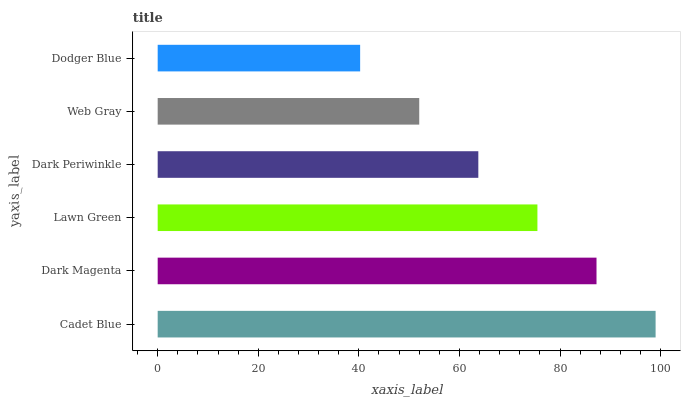Is Dodger Blue the minimum?
Answer yes or no. Yes. Is Cadet Blue the maximum?
Answer yes or no. Yes. Is Dark Magenta the minimum?
Answer yes or no. No. Is Dark Magenta the maximum?
Answer yes or no. No. Is Cadet Blue greater than Dark Magenta?
Answer yes or no. Yes. Is Dark Magenta less than Cadet Blue?
Answer yes or no. Yes. Is Dark Magenta greater than Cadet Blue?
Answer yes or no. No. Is Cadet Blue less than Dark Magenta?
Answer yes or no. No. Is Lawn Green the high median?
Answer yes or no. Yes. Is Dark Periwinkle the low median?
Answer yes or no. Yes. Is Dark Magenta the high median?
Answer yes or no. No. Is Dodger Blue the low median?
Answer yes or no. No. 